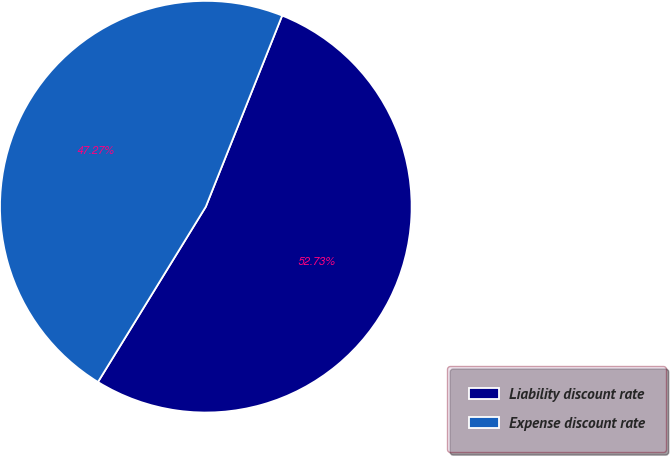Convert chart. <chart><loc_0><loc_0><loc_500><loc_500><pie_chart><fcel>Liability discount rate<fcel>Expense discount rate<nl><fcel>52.73%<fcel>47.27%<nl></chart> 